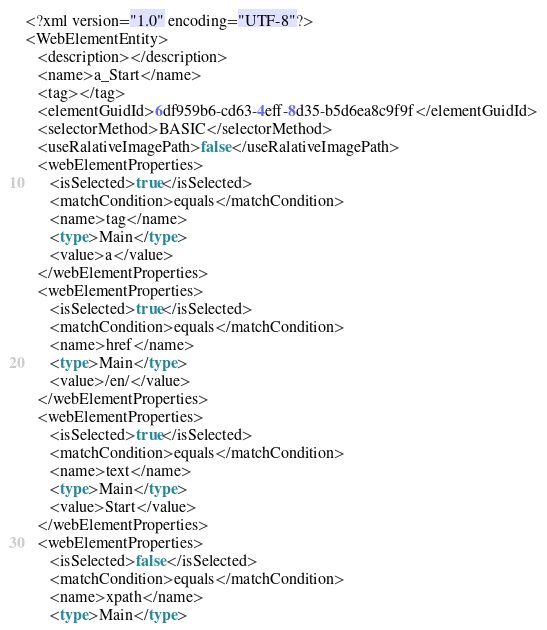Convert code to text. <code><loc_0><loc_0><loc_500><loc_500><_Rust_><?xml version="1.0" encoding="UTF-8"?>
<WebElementEntity>
   <description></description>
   <name>a_Start</name>
   <tag></tag>
   <elementGuidId>6df959b6-cd63-4eff-8d35-b5d6ea8c9f9f</elementGuidId>
   <selectorMethod>BASIC</selectorMethod>
   <useRalativeImagePath>false</useRalativeImagePath>
   <webElementProperties>
      <isSelected>true</isSelected>
      <matchCondition>equals</matchCondition>
      <name>tag</name>
      <type>Main</type>
      <value>a</value>
   </webElementProperties>
   <webElementProperties>
      <isSelected>true</isSelected>
      <matchCondition>equals</matchCondition>
      <name>href</name>
      <type>Main</type>
      <value>/en/</value>
   </webElementProperties>
   <webElementProperties>
      <isSelected>true</isSelected>
      <matchCondition>equals</matchCondition>
      <name>text</name>
      <type>Main</type>
      <value>Start</value>
   </webElementProperties>
   <webElementProperties>
      <isSelected>false</isSelected>
      <matchCondition>equals</matchCondition>
      <name>xpath</name>
      <type>Main</type></code> 